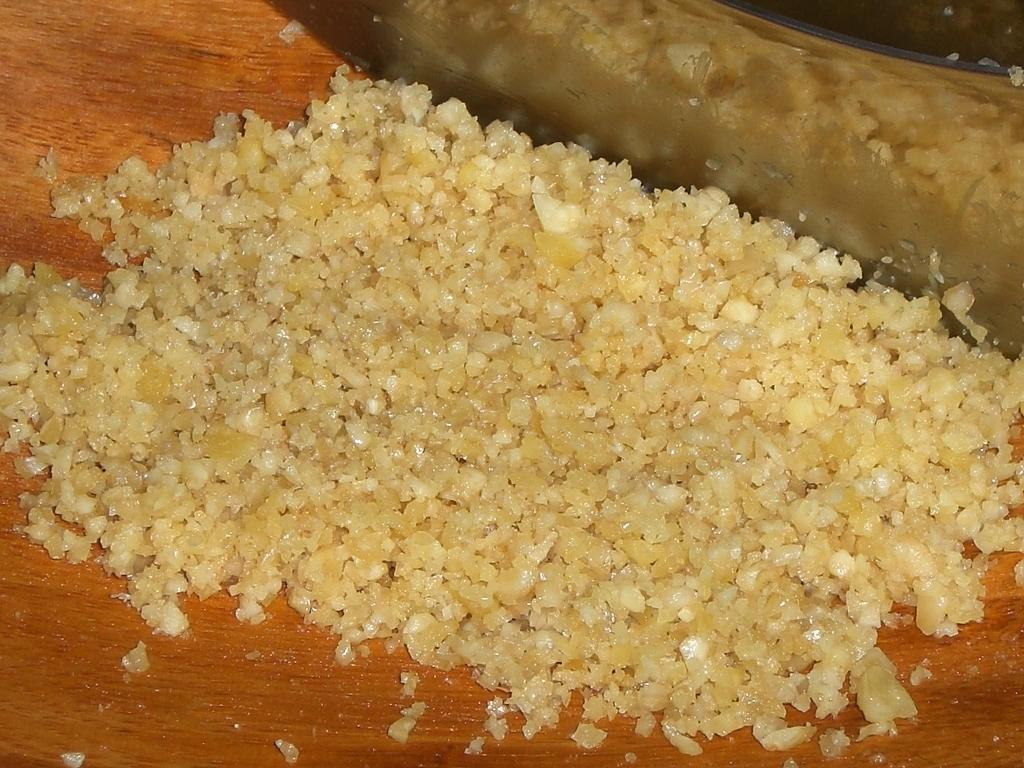What is the main object on which the food is placed in the image? There is food on a wooden plank in the image. What utensil is located near the wooden plank? There is a knife beside the wooden plank in the image. Can you see a kitten playing with the knife in the image? No, there is no kitten present in the image. 